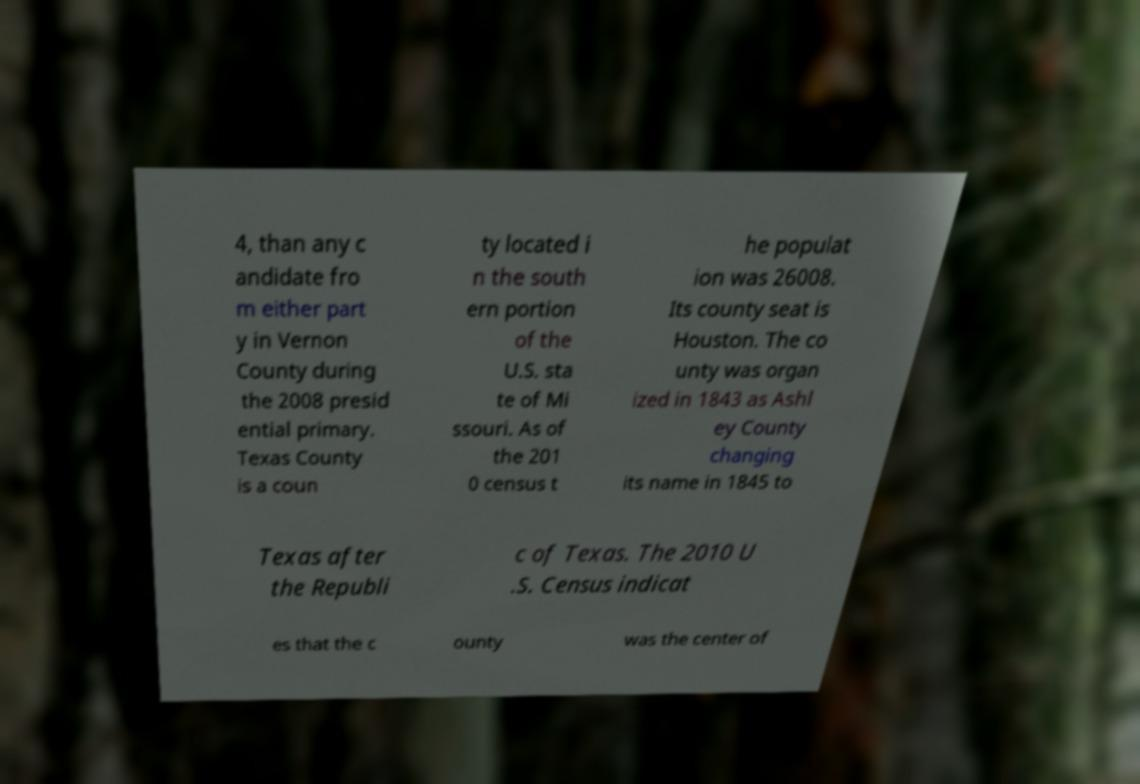I need the written content from this picture converted into text. Can you do that? 4, than any c andidate fro m either part y in Vernon County during the 2008 presid ential primary. Texas County is a coun ty located i n the south ern portion of the U.S. sta te of Mi ssouri. As of the 201 0 census t he populat ion was 26008. Its county seat is Houston. The co unty was organ ized in 1843 as Ashl ey County changing its name in 1845 to Texas after the Republi c of Texas. The 2010 U .S. Census indicat es that the c ounty was the center of 